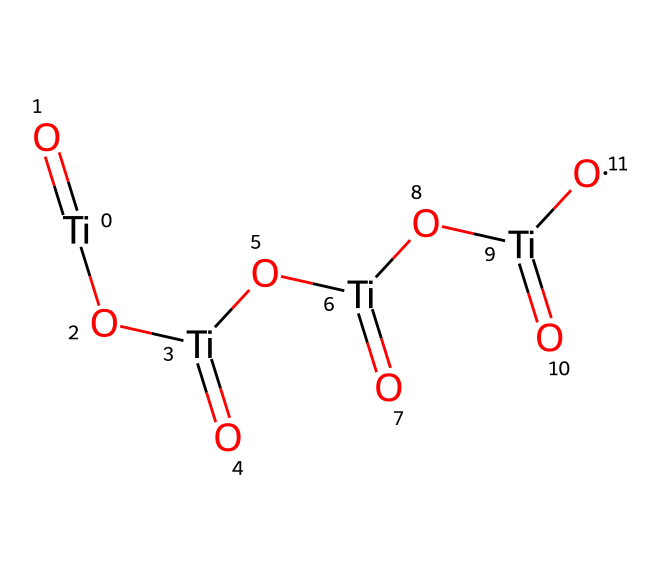What is the chemical name of this compound? The SMILES representation indicates the presence of titanium and oxygen in a specific arrangement, which corresponds to titanium dioxide.
Answer: titanium dioxide How many titanium atoms are present in this structure? By analyzing the SMILES code, we count the number of titanium representations, which shows there are four titanium atoms depicted.
Answer: four What is the total number of oxygen atoms in this chemical? Each titanium is bonded to two oxygen atoms as seen from the chemical structure, leading to a total count of eight oxygen atoms in the arrangement.
Answer: eight What type of bonding is predominant in this structure? The SMILES shows that the bonding between titanium and oxygen atoms includes multiple double bonds representing ionic or covalent nature, typical of metal-oxide compounds.
Answer: covalent How many double bonds are present in this structure? Analyzing the structure in the SMILES reveals that each titanium-oxygen pairing is a double bond, totaling four double bonds in the entirety of the compound.
Answer: four Is this compound an oxide or a hydroxide? The presence of titanium and only oxygen in the structure indicates that it is an oxide. Hydroxides would require the presence of hydroxyl groups, which are absent here.
Answer: oxide What is the general application of titanium dioxide in sunscreen? Titanium dioxide is widely recognized for its UV-filtering properties, providing physical protection against ultraviolet radiation when used in sunscreens.
Answer: UV filter 